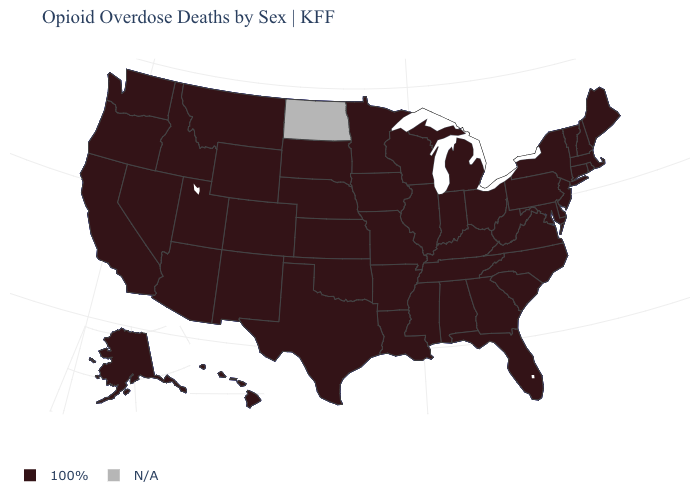What is the value of Alaska?
Concise answer only. 100%. What is the value of Kentucky?
Keep it brief. 100%. What is the lowest value in the West?
Short answer required. 100%. Among the states that border Virginia , which have the lowest value?
Keep it brief. Kentucky, Maryland, North Carolina, Tennessee, West Virginia. Among the states that border West Virginia , which have the lowest value?
Keep it brief. Kentucky, Maryland, Ohio, Pennsylvania, Virginia. What is the value of Nebraska?
Answer briefly. 100%. Name the states that have a value in the range 100%?
Quick response, please. Alabama, Alaska, Arizona, Arkansas, California, Colorado, Connecticut, Delaware, Florida, Georgia, Hawaii, Idaho, Illinois, Indiana, Iowa, Kansas, Kentucky, Louisiana, Maine, Maryland, Massachusetts, Michigan, Minnesota, Mississippi, Missouri, Montana, Nebraska, Nevada, New Hampshire, New Jersey, New Mexico, New York, North Carolina, Ohio, Oklahoma, Oregon, Pennsylvania, Rhode Island, South Carolina, South Dakota, Tennessee, Texas, Utah, Vermont, Virginia, Washington, West Virginia, Wisconsin, Wyoming. Among the states that border North Carolina , which have the lowest value?
Give a very brief answer. Georgia, South Carolina, Tennessee, Virginia. Among the states that border California , which have the highest value?
Write a very short answer. Arizona, Nevada, Oregon. What is the highest value in states that border Kentucky?
Keep it brief. 100%. What is the lowest value in the Northeast?
Short answer required. 100%. What is the value of South Dakota?
Write a very short answer. 100%. Among the states that border New Hampshire , which have the highest value?
Give a very brief answer. Maine, Massachusetts, Vermont. 